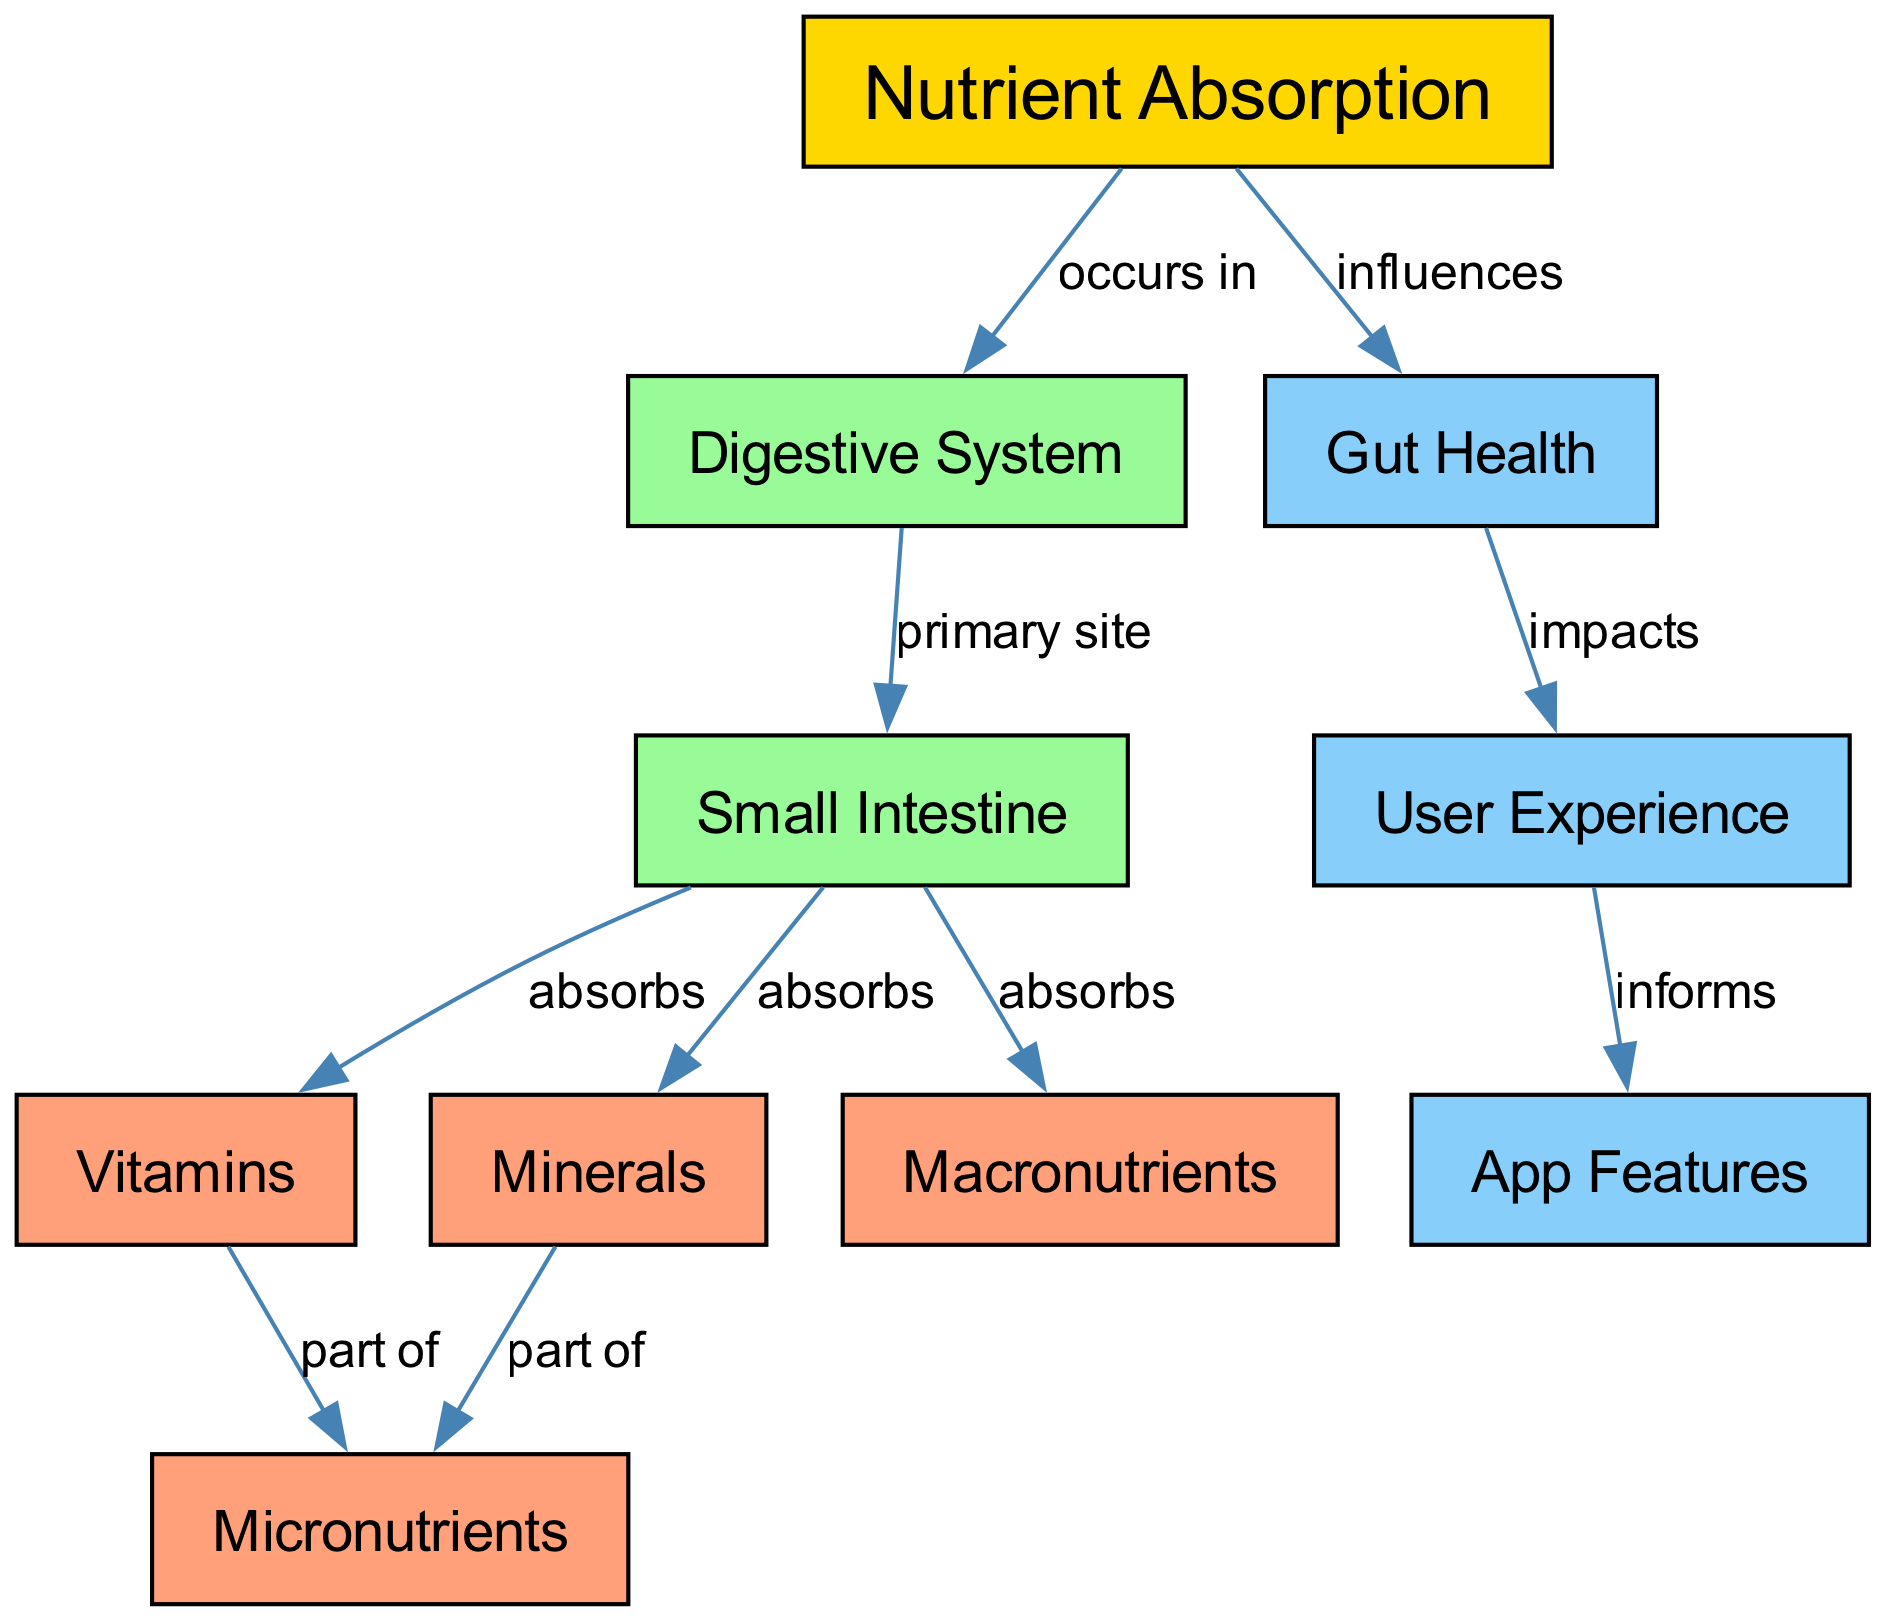What influences nutrient absorption? In the diagram, the edge labeled 'influences' connects the node 'nutrient absorption' with the node 'gut health', indicating that gut health is a factor that affects how nutrients are absorbed.
Answer: gut health What is the primary site of nutrient absorption? The edge labeled 'primary site' connects 'digestive system' with 'small intestine', which indicates that the small intestine is the main location where nutrient absorption occurs.
Answer: small intestine How many types of nutrients does the small intestine absorb? There are three edges connecting 'small intestine' to 'vitamins', 'minerals', and 'macronutrients'. Thus, counting these distinct relationships shows that the small intestine absorbs three types of nutrients.
Answer: three What do vitamins and minerals belong to? The edges labeled 'part of' from 'vitamins' and 'minerals' both point to 'micronutrients', indicating that both vitamins and minerals are categorized under micronutrients.
Answer: micronutrients How does gut health impact user experience? The edge labeled 'impacts' shows a connection from 'gut health' to 'user experience', meaning that gut health directly affects the overall user experience in nutrition-related applications.
Answer: user experience What informs app features? The edge labeled 'informs' connects 'user experience' with 'app features', signifying that insights from user experience guide the development and design of app features.
Answer: app features What components make up macronutrients? The concept map does not specify the individual components of macronutrients; thus, it does not provide direct information about their specific constituents. However, it indicates that macronutrients are absorbed in the small intestine.
Answer: Not specified How many nodes are there in the concept map? By counting each node listed in the data, we find that there are ten distinct nodes in the diagram, reflecting the different concepts related to nutrient absorption.
Answer: ten What absorbs micronutrients? The diagram does not specify an entity that absorbs micronutrients directly; however, it shows that vitamins and minerals are part of micronutrients and are absorbed by the small intestine, which suggests that they might also be absorbed here if grouped under micronutrients.
Answer: small intestine 